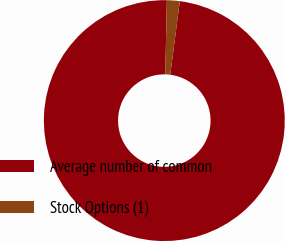Convert chart. <chart><loc_0><loc_0><loc_500><loc_500><pie_chart><fcel>Average number of common<fcel>Stock Options (1)<nl><fcel>98.28%<fcel>1.72%<nl></chart> 